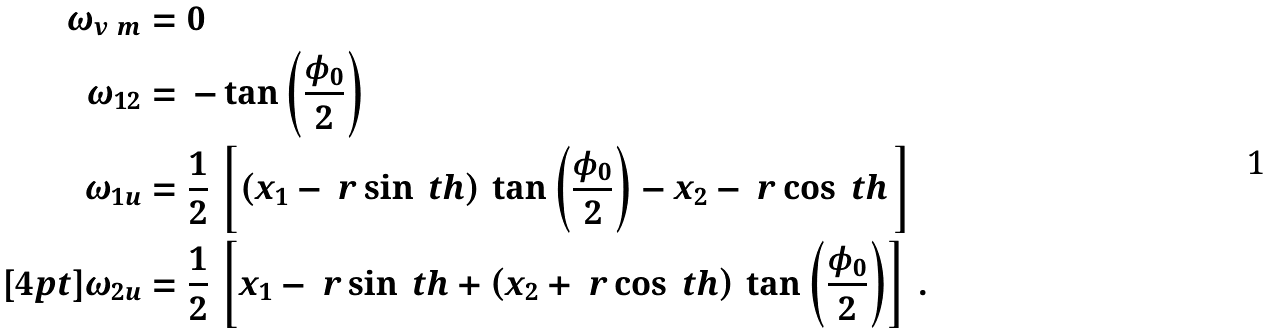Convert formula to latex. <formula><loc_0><loc_0><loc_500><loc_500>\omega _ { v \ m } & = 0 \\ \omega _ { 1 2 } & = \, - \tan \left ( \frac { \phi _ { 0 } } { 2 } \right ) \\ \omega _ { 1 u } & = \frac { 1 } { 2 } \, \left [ \left ( x _ { 1 } - \ r \sin \ t h \/ \right ) \, \tan \left ( \frac { \phi _ { 0 } } { 2 } \right ) - x _ { 2 } - \ r \cos \ t h \, \right ] \\ [ 4 p t ] \omega _ { 2 u } & = \frac { 1 } { 2 } \, \left [ x _ { 1 } - \ r \sin \ t h + \left ( x _ { 2 } + \ r \cos \ t h \/ \right ) \, \tan \left ( \frac { \phi _ { 0 } } { 2 } \right ) \right ] \, .</formula> 